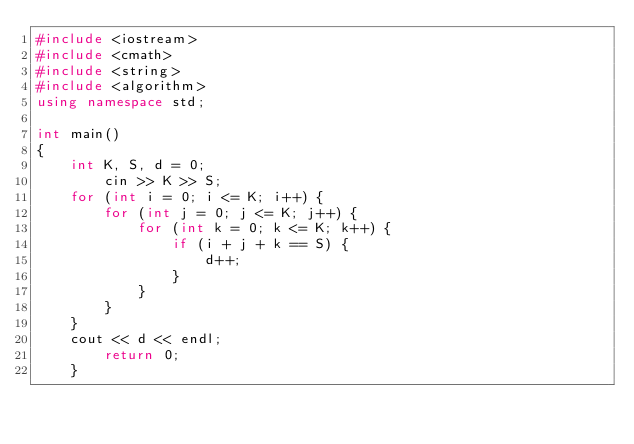Convert code to text. <code><loc_0><loc_0><loc_500><loc_500><_C++_>#include <iostream>
#include <cmath>
#include <string>
#include <algorithm>
using namespace std;

int main()
{
	int K, S, d = 0;
		cin >> K >> S;
	for (int i = 0; i <= K; i++) {
		for (int j = 0; j <= K; j++) {
			for (int k = 0; k <= K; k++) {
				if (i + j + k == S) {
					d++;
				}
			}
		}
	}
	cout << d << endl;
		return 0;
	}</code> 